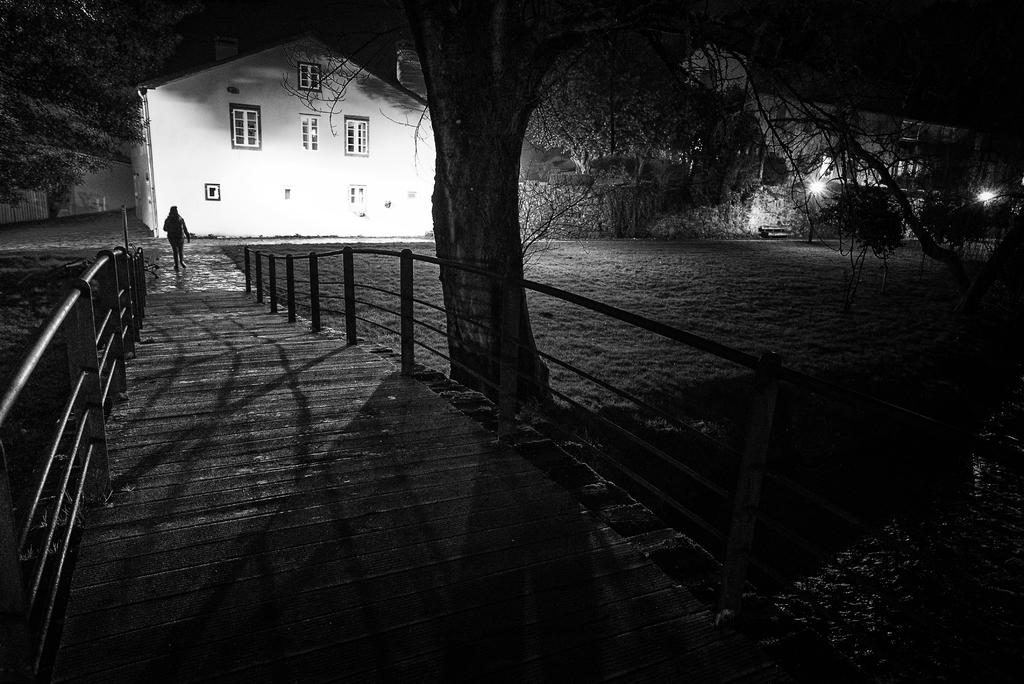What is located in the foreground of the image? There is a bridge and a tree in the foreground of the image. What can be seen in the background of the image? There are buildings, trees, lights, and grass land in the background of the image. Can you describe the person in the image? There is a person walking in the background of the image. What type of wren can be seen sitting on the sofa in the image? There is no wren or sofa present in the image. What is the person's hope for the future, as depicted in the image? The image does not provide any information about the person's hopes or future plans. 